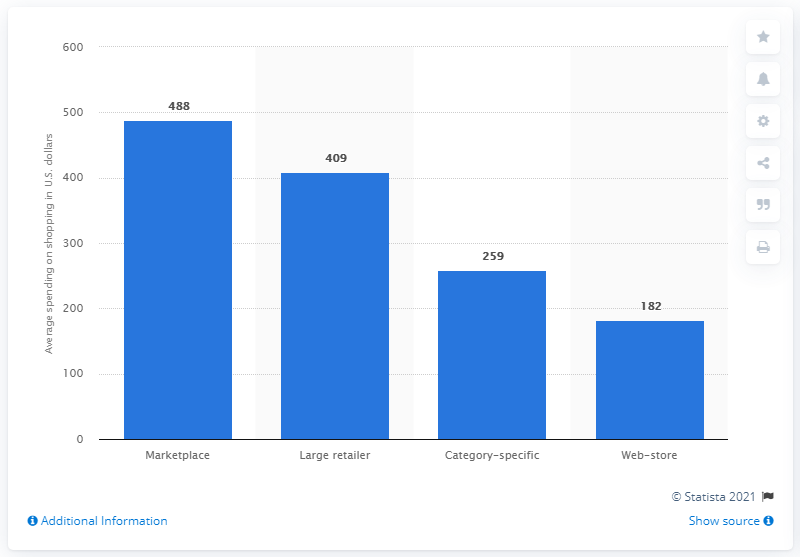Give some essential details in this illustration. In 2017, the average amount of dollars spent per shopper by marketplaces was 488. 